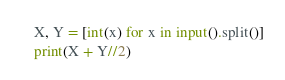<code> <loc_0><loc_0><loc_500><loc_500><_Python_>X, Y = [int(x) for x in input().split()]
print(X + Y//2)</code> 